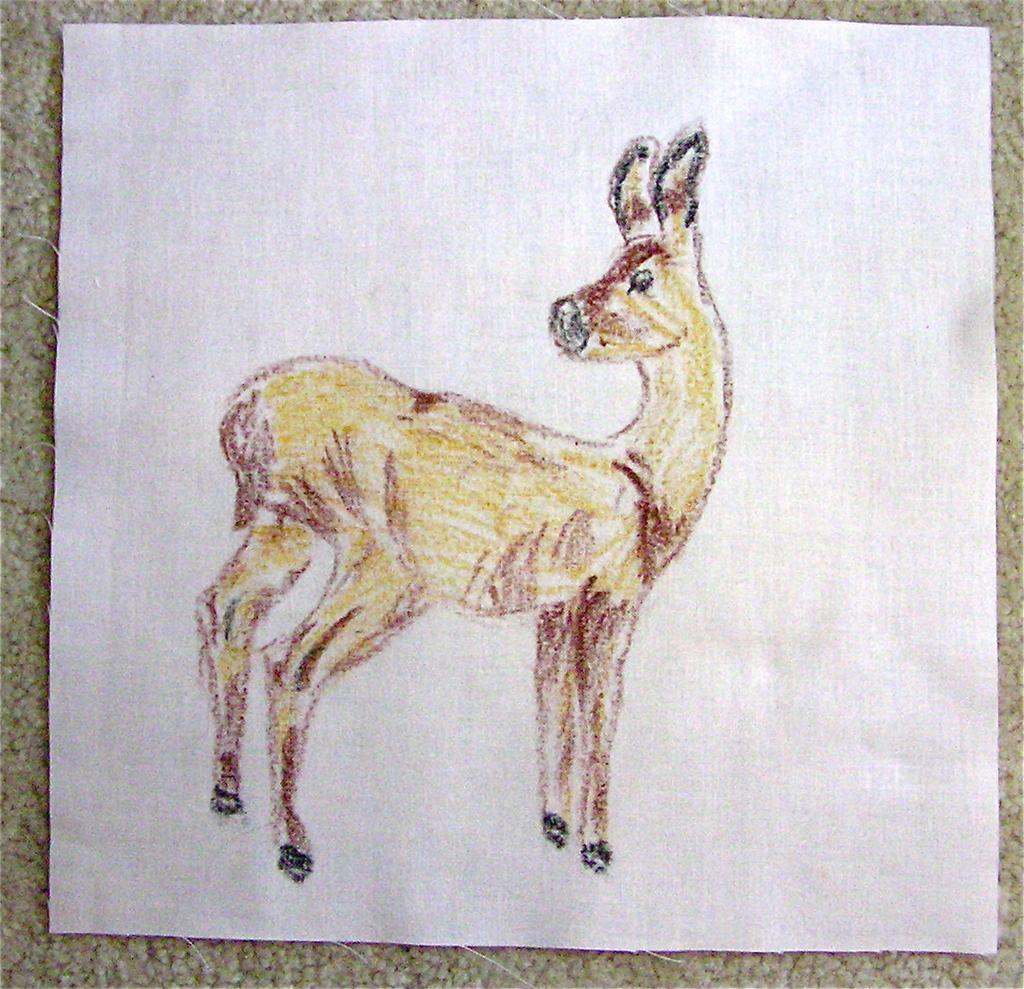What is present in the image that is related to writing or drawing? There is a paper in the image that contains a drawing. What is depicted in the drawing on the paper? The drawing on the paper is of an animal. What colors are used to create the animal in the drawing? The animal's color is yellow and brown. How does the guide help the animal in the image? There is no guide present in the image; it only contains a drawing of an animal. 